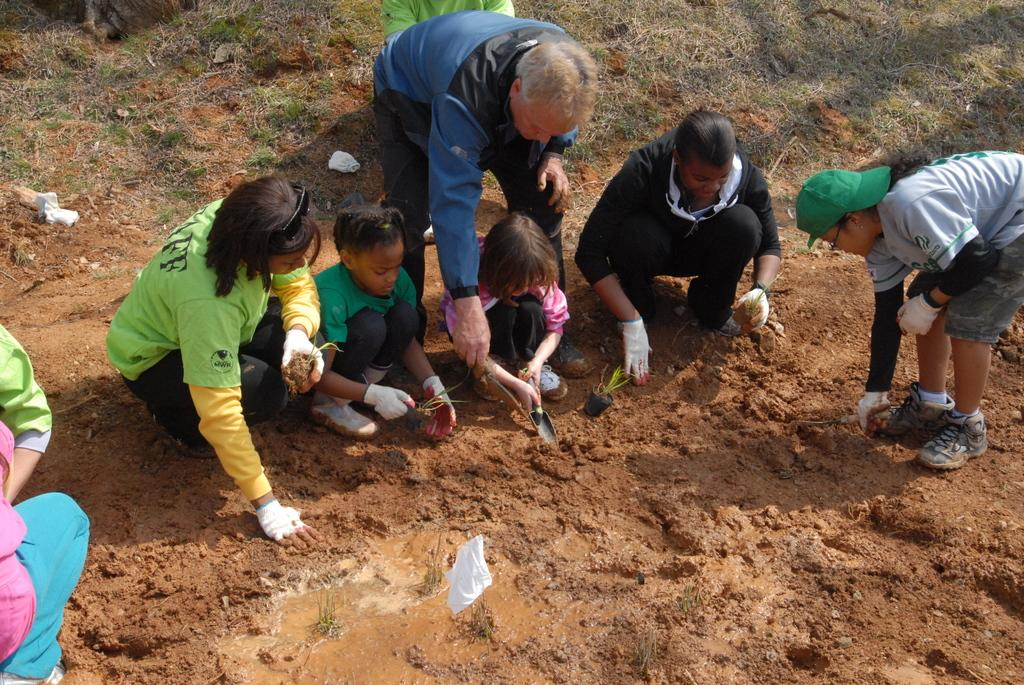Who or what is present in the image? There are people in the image. Where are the people located in the image? The people are in the center of the image. What are the people doing in the image? The people are planting. How many quills are being used by the people in the image? There is no mention of quills in the image, so it is impossible to determine how many are being used. 